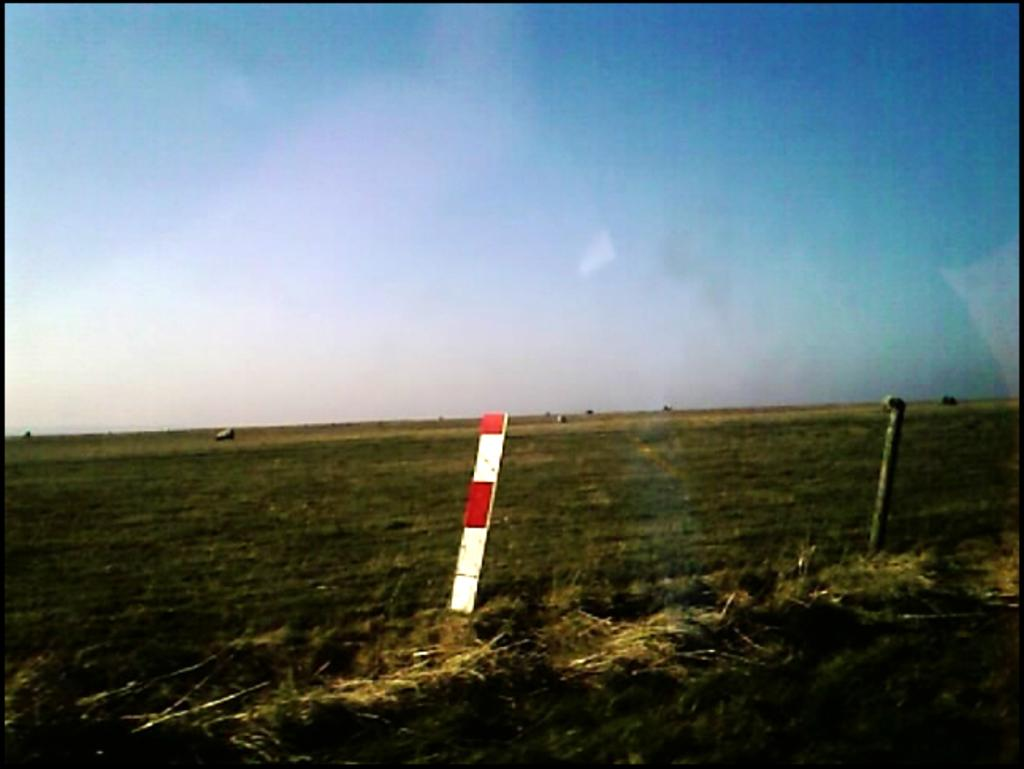What can be seen on the ground in the image? The ground is visible in the image, and there is grass on the ground. What else is present on the ground besides grass? There are poles and other objects on the ground. What is visible in the background of the image? The sky is visible in the background of the image. What type of zinc is present in the image? There is no zinc present in the image. What act is being performed by the objects in the image? The objects in the image are not performing any act; they are stationary. 